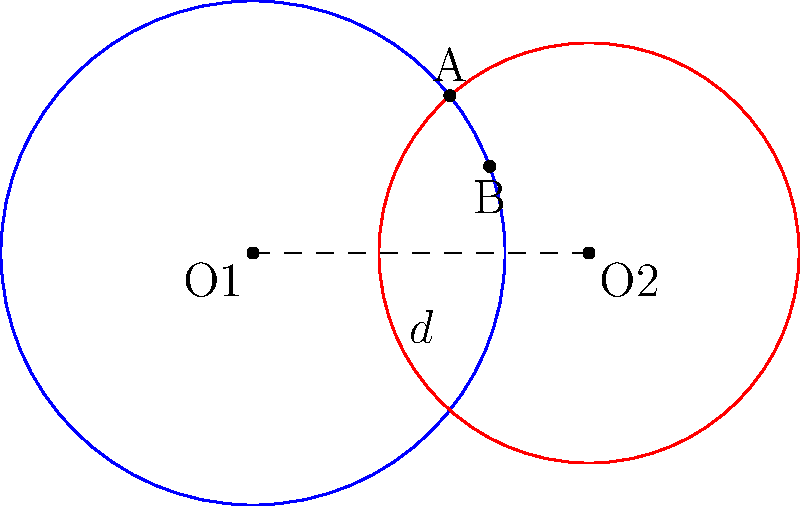In the Bank of Spain, two circular vault doors intersect as shown in the diagram. The blue circle represents the outer vault door with radius 3 meters, and the red circle represents the inner vault door with radius 2.5 meters. The centers of the circles are 4 meters apart. Calculate the area of the region where the two vault doors overlap (the lens-shaped region). To find the area of the lens-shaped region, we'll follow these steps:

1) First, we need to find the angle θ at the center of each circle subtended by the chord AB.

2) For the blue circle (O1):
   $$\cos(\theta/2) = \frac{d/2}{r1} = \frac{2}{3}$$
   $$\theta_1 = 2 \arccos(\frac{2}{3}) \approx 2.0944 \text{ radians}$$

3) For the red circle (O2):
   $$\cos(\theta/2) = \frac{d/2}{r2} = \frac{2}{2.5} = 0.8$$
   $$\theta_2 = 2 \arccos(0.8) \approx 1.2870 \text{ radians}$$

4) The area of a circular sector is given by $\frac{1}{2}r^2\theta$, where r is the radius and θ is the angle in radians.

5) The area of the triangle formed by the center and the two intersection points is $\frac{1}{2}r^2\sin(\theta)$.

6) The area of the lens is the sum of the two circular sectors minus the two triangles:

   $$A = (\frac{1}{2}r1^2\theta_1 + \frac{1}{2}r2^2\theta_2) - (\frac{1}{2}r1^2\sin(\theta_1) + \frac{1}{2}r2^2\sin(\theta_2))$$

7) Substituting the values:

   $$A = (\frac{1}{2}(3^2)(2.0944) + \frac{1}{2}(2.5^2)(1.2870)) - (\frac{1}{2}(3^2)\sin(2.0944) + \frac{1}{2}(2.5^2)\sin(1.2870))$$

8) Calculating:
   $$A \approx (9.4248 + 4.0219) - (4.0112 + 2.0645) \approx 7.3710 \text{ square meters}$$
Answer: 7.37 m² 